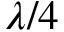<formula> <loc_0><loc_0><loc_500><loc_500>\lambda / 4</formula> 